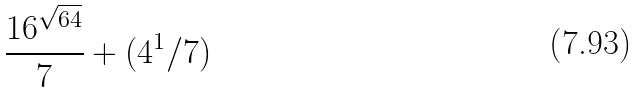Convert formula to latex. <formula><loc_0><loc_0><loc_500><loc_500>\frac { 1 6 ^ { \sqrt { 6 4 } } } { 7 } + ( 4 ^ { 1 } / 7 )</formula> 